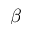Convert formula to latex. <formula><loc_0><loc_0><loc_500><loc_500>\beta</formula> 